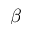Convert formula to latex. <formula><loc_0><loc_0><loc_500><loc_500>\beta</formula> 